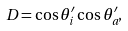<formula> <loc_0><loc_0><loc_500><loc_500>D = \cos \theta _ { i } ^ { \prime } \cos \theta _ { a } ^ { \prime } ,</formula> 